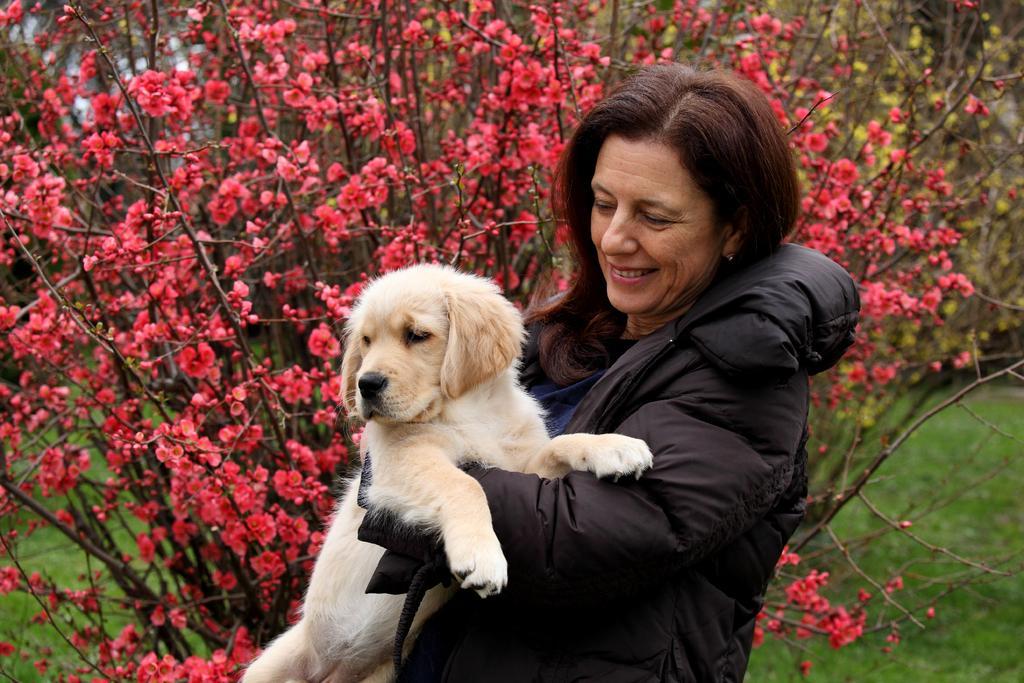Please provide a concise description of this image. In this image there is a person wearing jacket and holding a dog in the foreground. There is grass at the bottom. There are flowers on the plants, there are in the background. And there is sky at the top. 